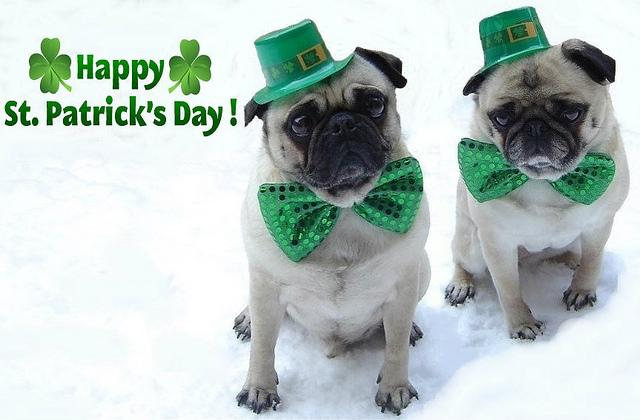What nationality is associated with the holiday being celebrated here?

Choices:
A) chinese
B) irish
C) french
D) italian irish 